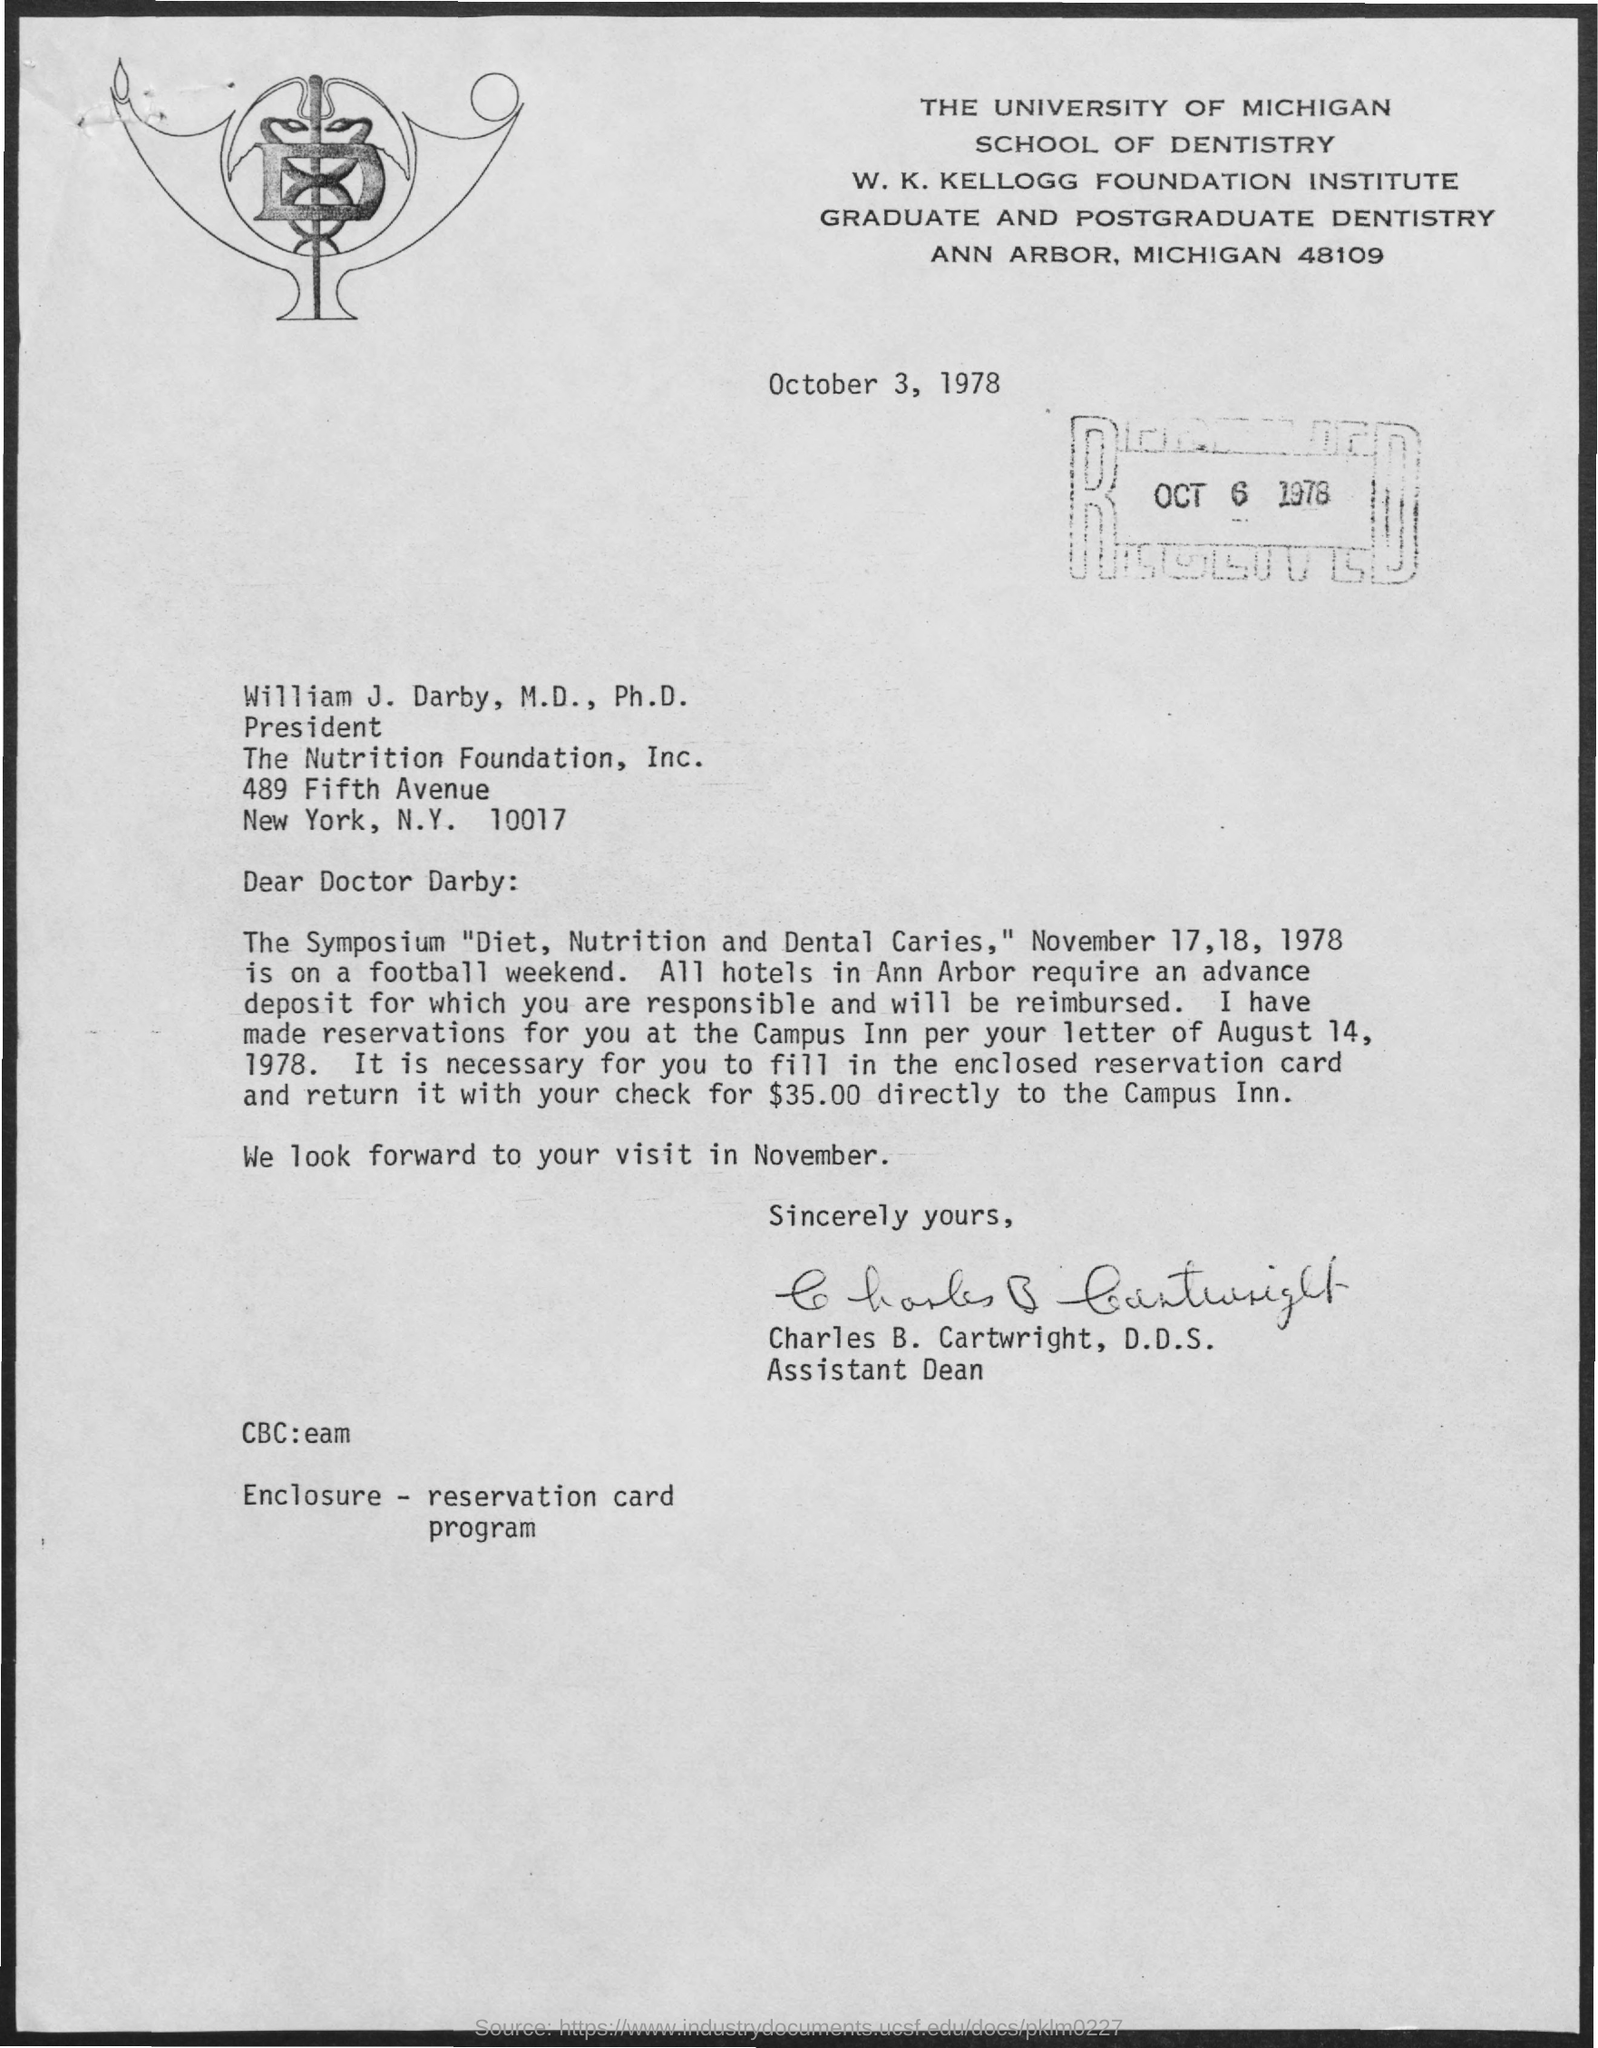What is the designation of Charles B. Cartwright, D.D.S.?
Provide a succinct answer. Assistant dean. What is the received date of this letter?
Your answer should be very brief. OCT 6  1978. 